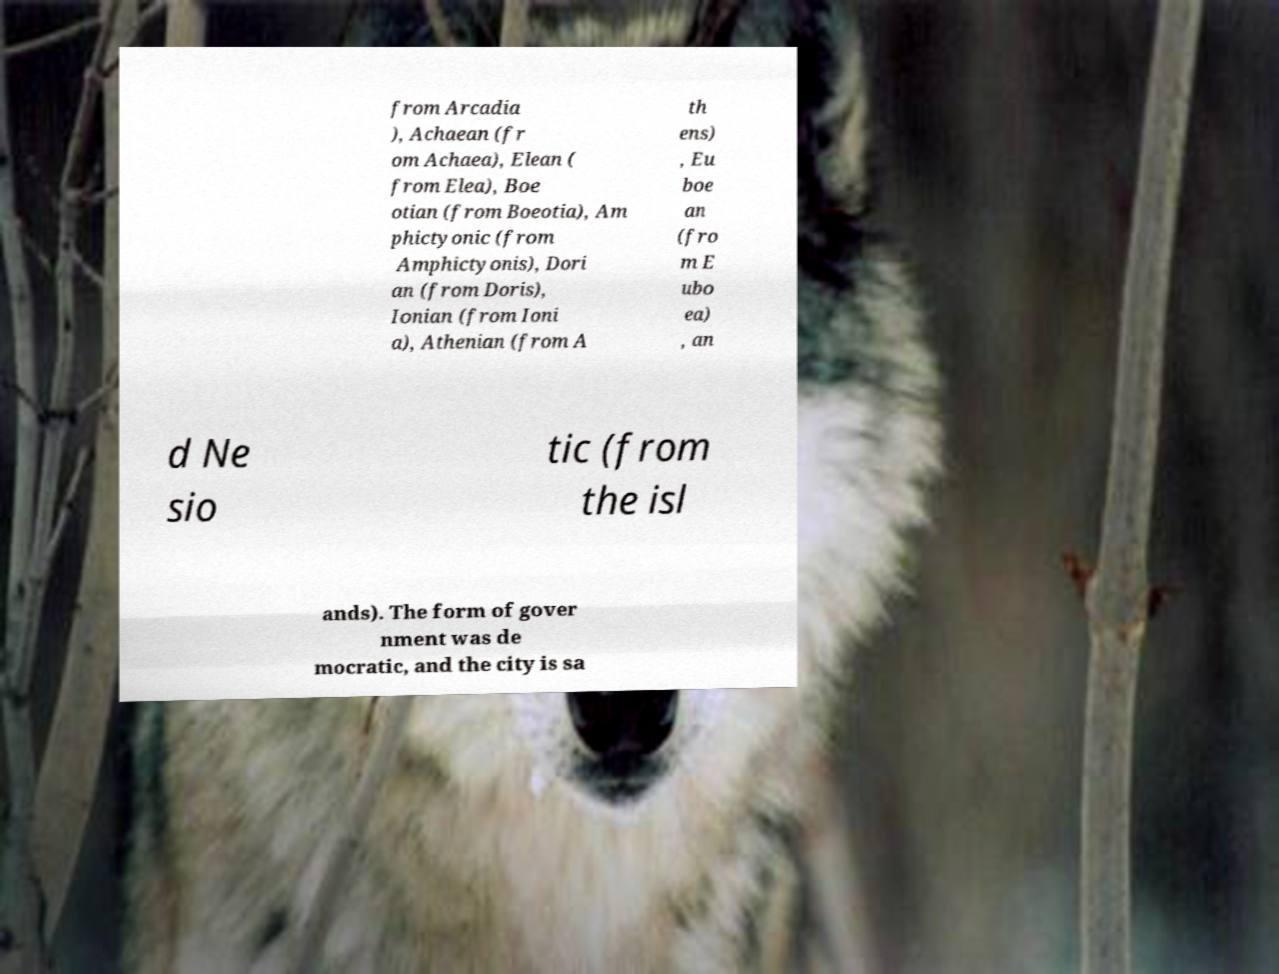What messages or text are displayed in this image? I need them in a readable, typed format. from Arcadia ), Achaean (fr om Achaea), Elean ( from Elea), Boe otian (from Boeotia), Am phictyonic (from Amphictyonis), Dori an (from Doris), Ionian (from Ioni a), Athenian (from A th ens) , Eu boe an (fro m E ubo ea) , an d Ne sio tic (from the isl ands). The form of gover nment was de mocratic, and the city is sa 